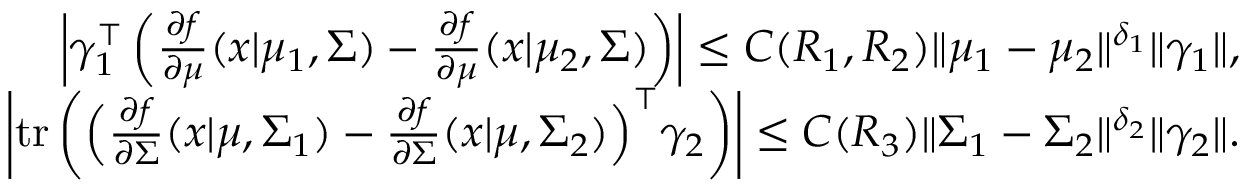Convert formula to latex. <formula><loc_0><loc_0><loc_500><loc_500>\begin{array} { r } { \left | \gamma _ { 1 } ^ { \top } \left ( \frac { \partial f } { \partial \mu } ( x | \mu _ { 1 } , \Sigma ) - \frac { \partial f } { \partial \mu } ( x | \mu _ { 2 } , \Sigma ) \right ) \right | \leq C ( R _ { 1 } , R _ { 2 } ) \| \mu _ { 1 } - \mu _ { 2 } \| ^ { \delta _ { 1 } } \| \gamma _ { 1 } \| , } \\ { \left | t r \left ( \left ( \frac { \partial f } { \partial \Sigma } ( x | \mu , \Sigma _ { 1 } ) - \frac { \partial f } { \partial \Sigma } ( x | \mu , \Sigma _ { 2 } ) \right ) ^ { \top } \gamma _ { 2 } \right ) \right | \leq C ( R _ { 3 } ) \| \Sigma _ { 1 } - \Sigma _ { 2 } \| ^ { \delta _ { 2 } } \| \gamma _ { 2 } \| . } \end{array}</formula> 